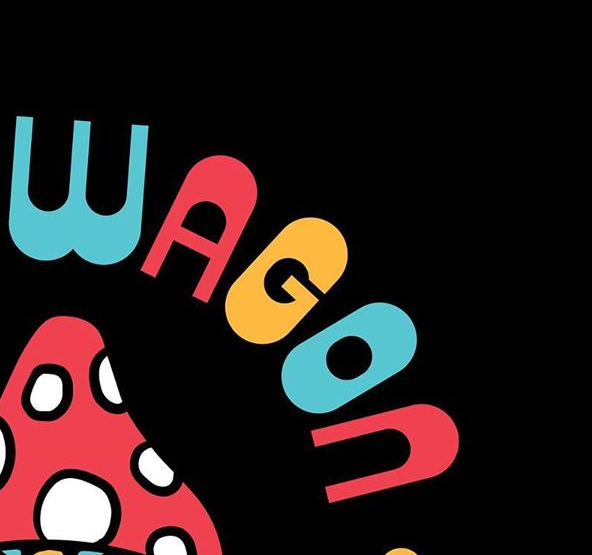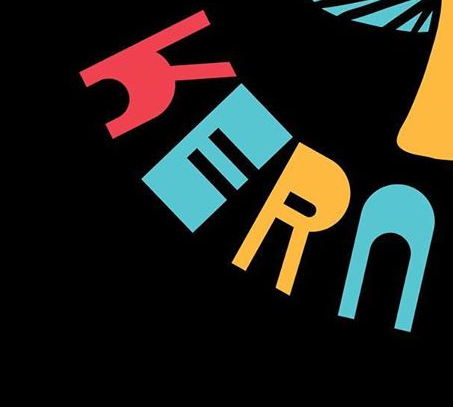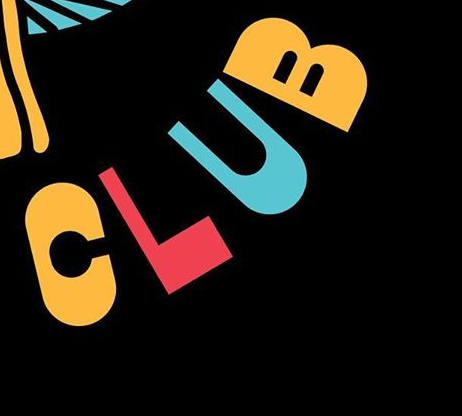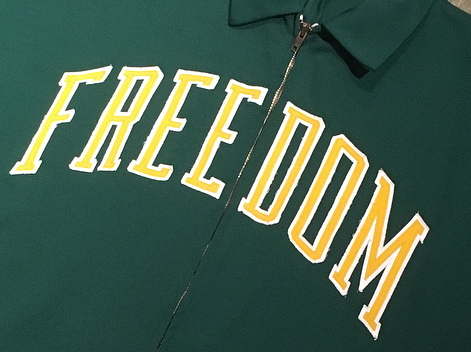What words are shown in these images in order, separated by a semicolon? WAGON; KERN; CLUB; FREEDOM 